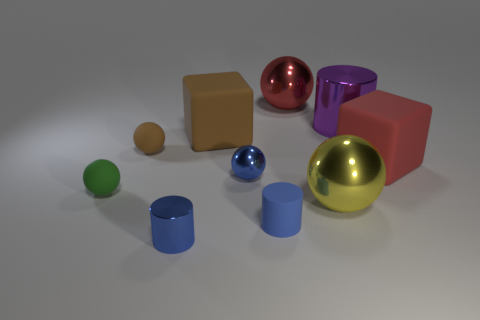Subtract all tiny blue matte cylinders. How many cylinders are left? 2 Subtract all cyan balls. How many blue cylinders are left? 2 Subtract all brown balls. How many balls are left? 4 Subtract 2 spheres. How many spheres are left? 3 Subtract all cylinders. How many objects are left? 7 Subtract all small purple metal objects. Subtract all tiny rubber spheres. How many objects are left? 8 Add 1 small green things. How many small green things are left? 2 Add 7 tiny gray blocks. How many tiny gray blocks exist? 7 Subtract 1 brown blocks. How many objects are left? 9 Subtract all purple cylinders. Subtract all brown cubes. How many cylinders are left? 2 